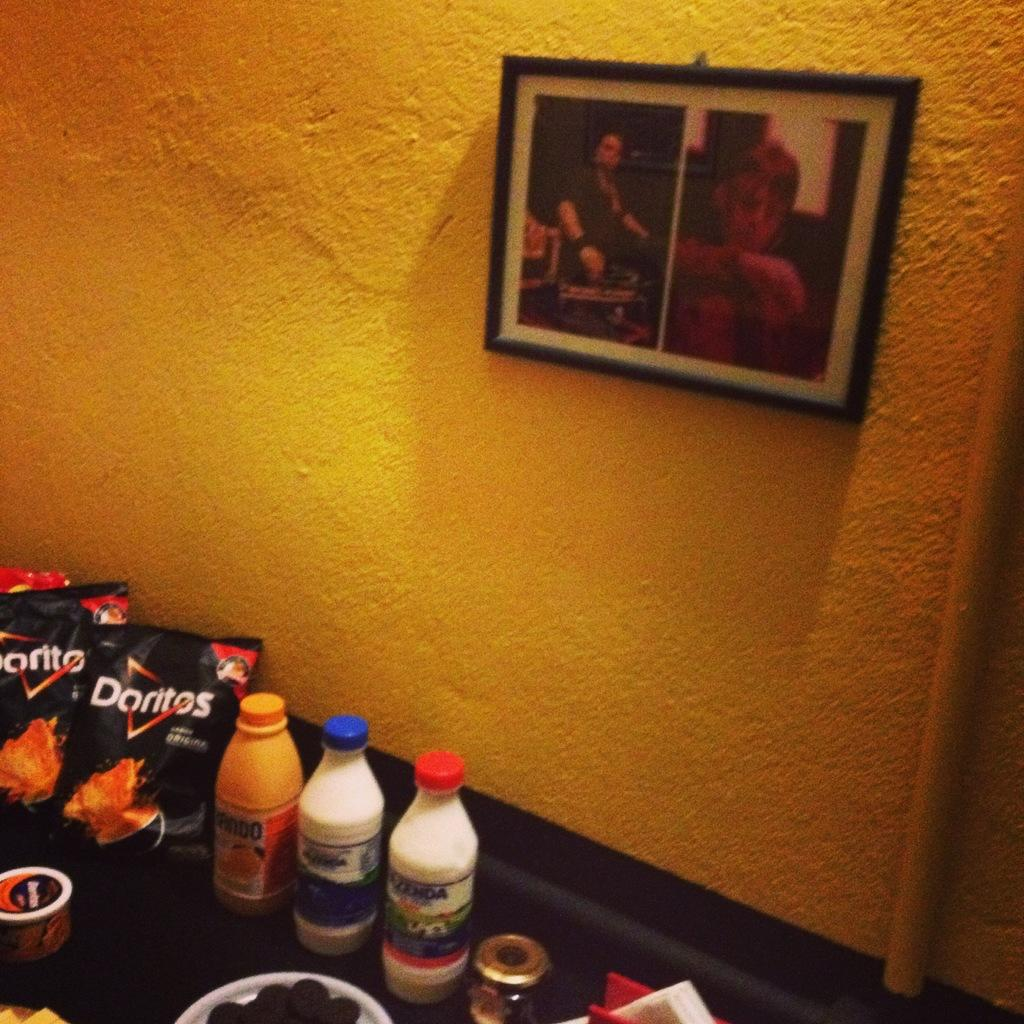What is hanging on the wall in the image? There is a frame on the wall in the image. What type of objects can be seen in the image besides the frame? There are bottles and packets in the image. Can you see the father jumping with a tiger in the image? There is no father, jumping, or tiger present in the image. 